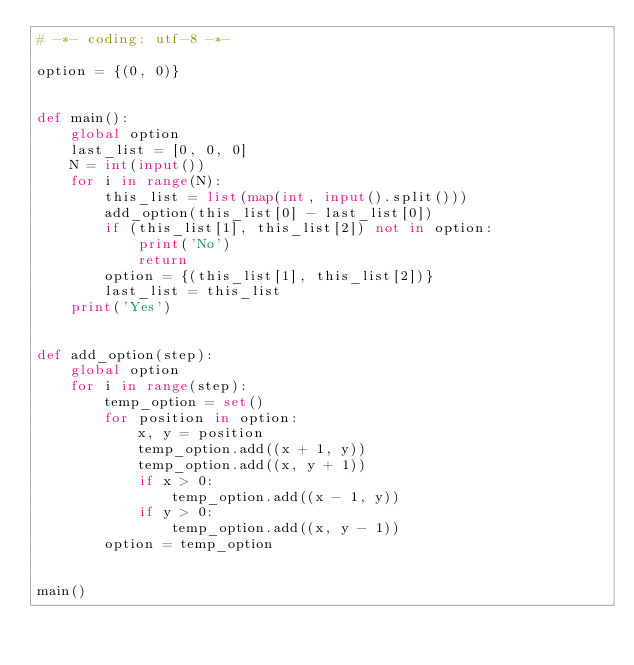Convert code to text. <code><loc_0><loc_0><loc_500><loc_500><_Python_># -*- coding: utf-8 -*-

option = {(0, 0)}


def main():
    global option
    last_list = [0, 0, 0]
    N = int(input())
    for i in range(N):
        this_list = list(map(int, input().split()))
        add_option(this_list[0] - last_list[0])
        if (this_list[1], this_list[2]) not in option:
            print('No')
            return
        option = {(this_list[1], this_list[2])}
        last_list = this_list
    print('Yes')


def add_option(step):
    global option
    for i in range(step):
        temp_option = set()
        for position in option:
            x, y = position
            temp_option.add((x + 1, y))
            temp_option.add((x, y + 1))
            if x > 0:
                temp_option.add((x - 1, y))
            if y > 0:
                temp_option.add((x, y - 1))
        option = temp_option


main()
</code> 